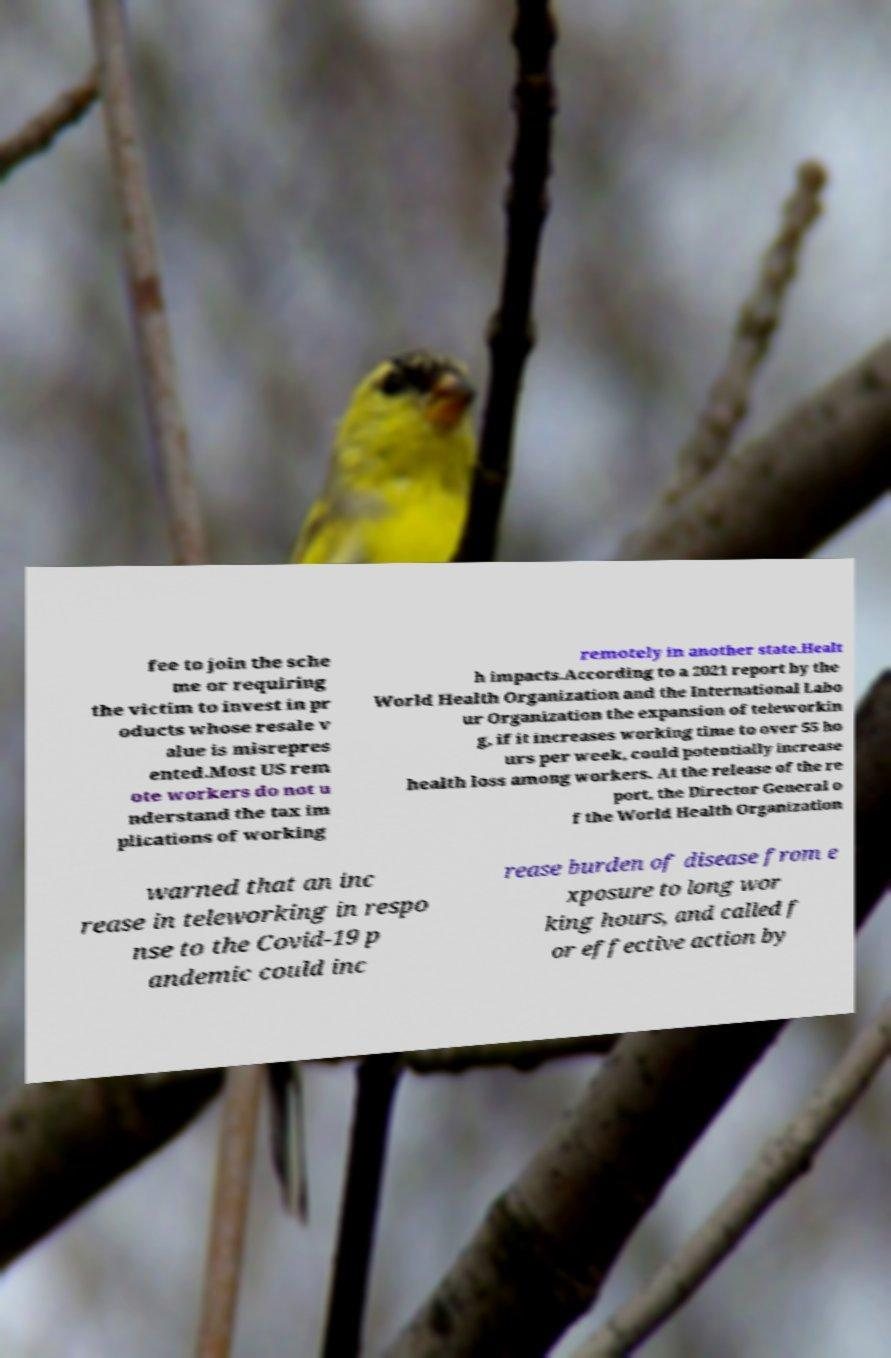Please identify and transcribe the text found in this image. fee to join the sche me or requiring the victim to invest in pr oducts whose resale v alue is misrepres ented.Most US rem ote workers do not u nderstand the tax im plications of working remotely in another state.Healt h impacts.According to a 2021 report by the World Health Organization and the International Labo ur Organization the expansion of teleworkin g, if it increases working time to over 55 ho urs per week, could potentially increase health loss among workers. At the release of the re port, the Director General o f the World Health Organization warned that an inc rease in teleworking in respo nse to the Covid-19 p andemic could inc rease burden of disease from e xposure to long wor king hours, and called f or effective action by 